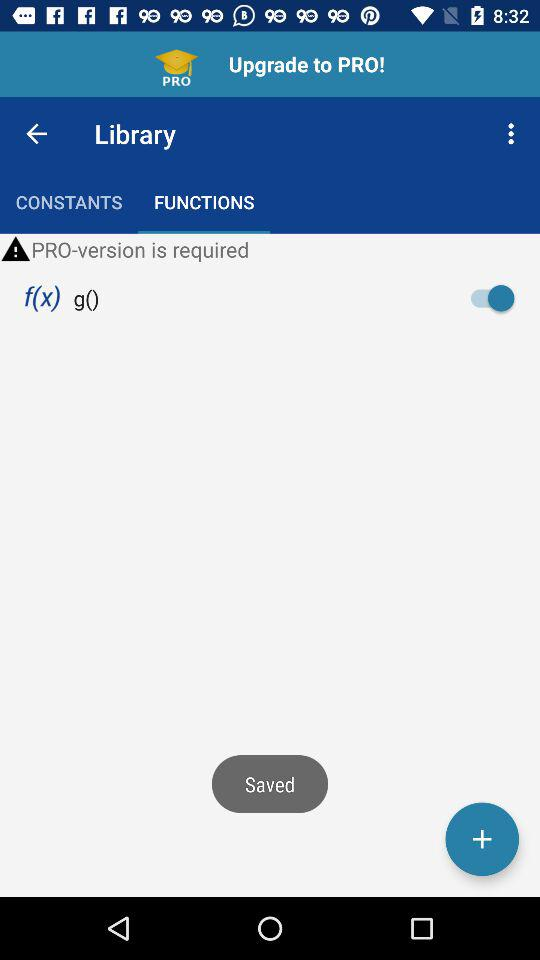What is the application name?
When the provided information is insufficient, respond with <no answer>. <no answer> 